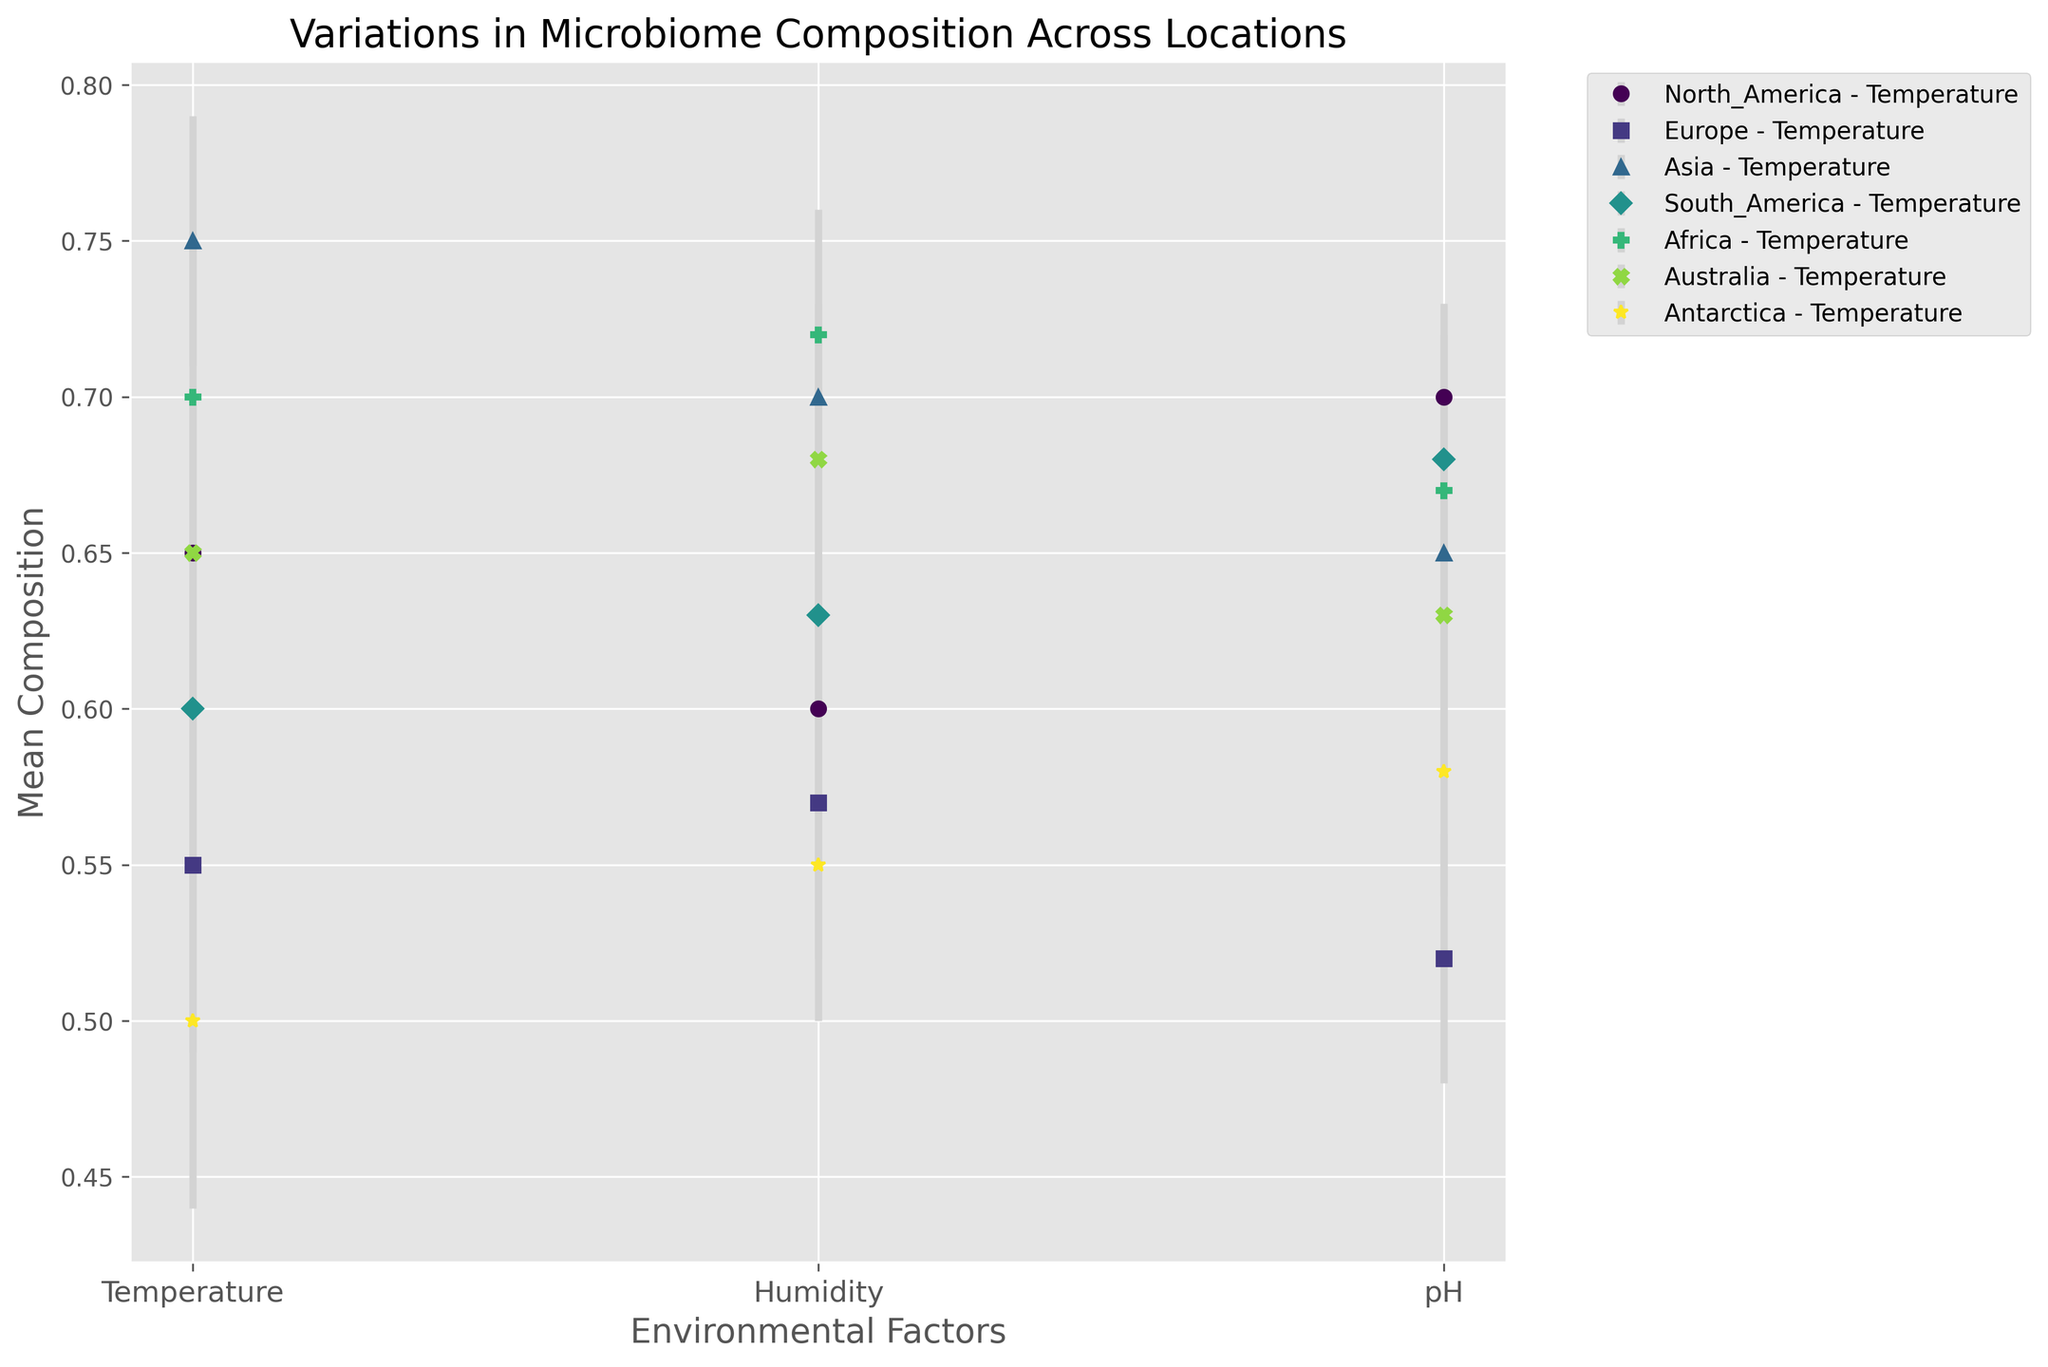Which location shows the highest mean microbiome composition for Temperature? Observing the plot, the mean compositions for Temperature across locations are: North America (0.65), Europe (0.55), Asia (0.75), South America (0.60), Africa (0.70), Australia (0.65), Antarctica (0.50). Asia has the highest mean composition at 0.75.
Answer: Asia Which environmental factor shows the least variability in microbiome composition for Africa? To determine variability, we look at the standard deviations for Africa: Temperature (0.05), Humidity (0.04), pH (0.03). The smallest standard deviation is 0.03 for the pH factor.
Answer: pH What is the difference in mean microbiome composition for pH between Asia and Europe? From the plot, mean compositions for pH are Asia (0.65) and Europe (0.52). Difference: 0.65 - 0.52 = 0.13.
Answer: 0.13 Which environmental factor shows the highest mean composition overall? Comparing compositions across all factors and locations, the highest mean composition is for Temperature in Asia (0.75).
Answer: Temperature in Asia How does the composition variability for Humidity in North America compare to that in Europe? The standard deviations for Humidity are North America (0.04) and Europe (0.05). Europe has a higher variability than North America.
Answer: Europe has higher variability For South America, which environmental factor has the highest mean composition, and what is it? In South America, mean compositions are: Temperature (0.60), Humidity (0.63), pH (0.68). The highest is for pH at 0.68.
Answer: pH, 0.68 Which continent shows the greatest variability for Temperature? Looking at the standard deviations for Temperature: North America (0.05), Europe (0.06), Asia (0.04), South America (0.06), Africa (0.05), Australia (0.03), Antarctica (0.06). Europe, South America, and Antarctica all have the highest variability at 0.06.
Answer: Europe, South America, Antarctica What is the average mean composition for pH across all locations? Mean compositions for pH are: North America (0.70), Europe (0.52), Asia (0.65), South America (0.68), Africa (0.67), Australia (0.63), Antarctica (0.58). Sum these values and divide by 7. (0.70 + 0.52 + 0.65 + 0.68 + 0.67 + 0.63 + 0.58) / 7 = 4.43 / 7 ≈ 0.63.
Answer: 0.63 Among all locations, which one has the lowest mean microbiome composition for Temperature, and what is it? Reviewing Temperature data: North America (0.65), Europe (0.55), Asia (0.75), South America (0.60), Africa (0.70), Australia (0.65), Antarctica (0.50). Antarctica has the lowest mean composition at 0.50.
Answer: Antarctica, 0.50 